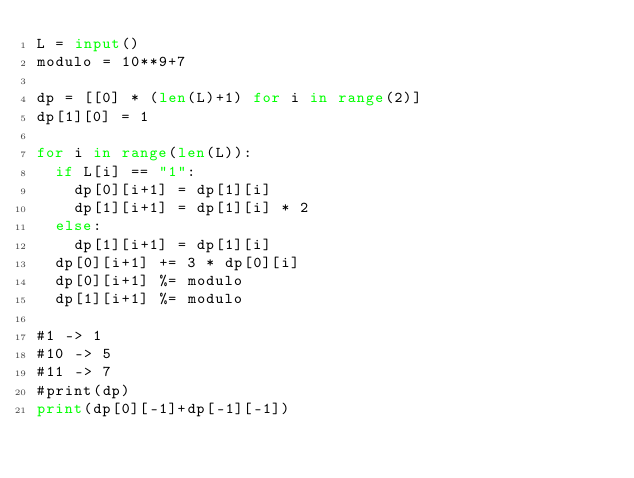<code> <loc_0><loc_0><loc_500><loc_500><_Python_>L = input()
modulo = 10**9+7

dp = [[0] * (len(L)+1) for i in range(2)]
dp[1][0] = 1
  
for i in range(len(L)):
  if L[i] == "1":
    dp[0][i+1] = dp[1][i] 
    dp[1][i+1] = dp[1][i] * 2
  else:
    dp[1][i+1] = dp[1][i]
  dp[0][i+1] += 3 * dp[0][i]
  dp[0][i+1] %= modulo
  dp[1][i+1] %= modulo

#1 -> 1
#10 -> 5
#11 -> 7
#print(dp)
print(dp[0][-1]+dp[-1][-1])
</code> 